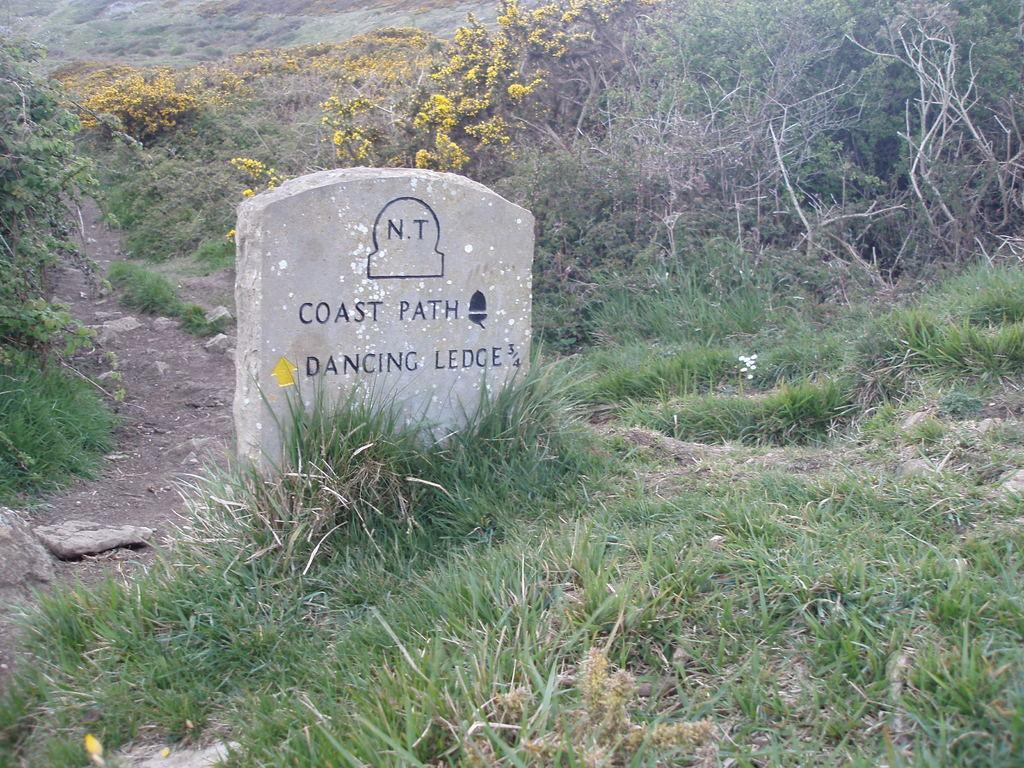Could you give a brief overview of what you see in this image? This picture might be taken from outside of the city. In this image, we can see a wall, on that wall, we can see some text written on it. On the right side, we can see some trees. On the left side, we can see some trees. In the background, we can see some trees with flowers which are in yellow color, at the bottom there is a grass and a land with some stones. 